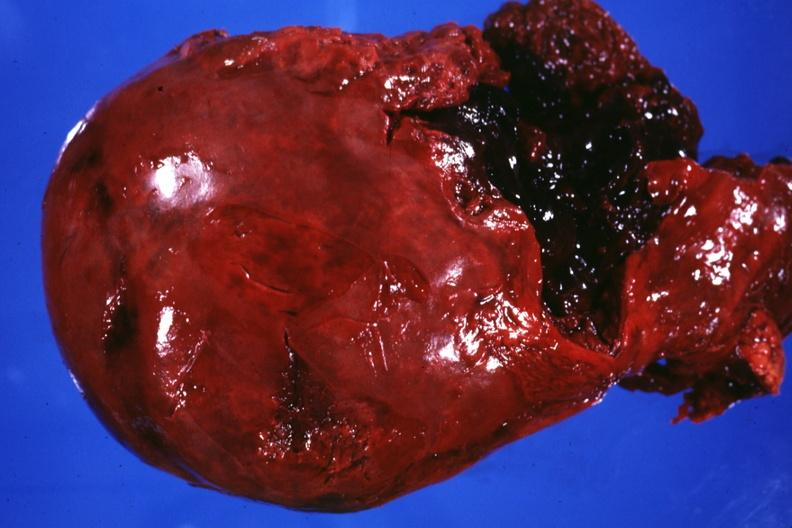does this image show external view of liver severe laceration between lobes?
Answer the question using a single word or phrase. Yes 